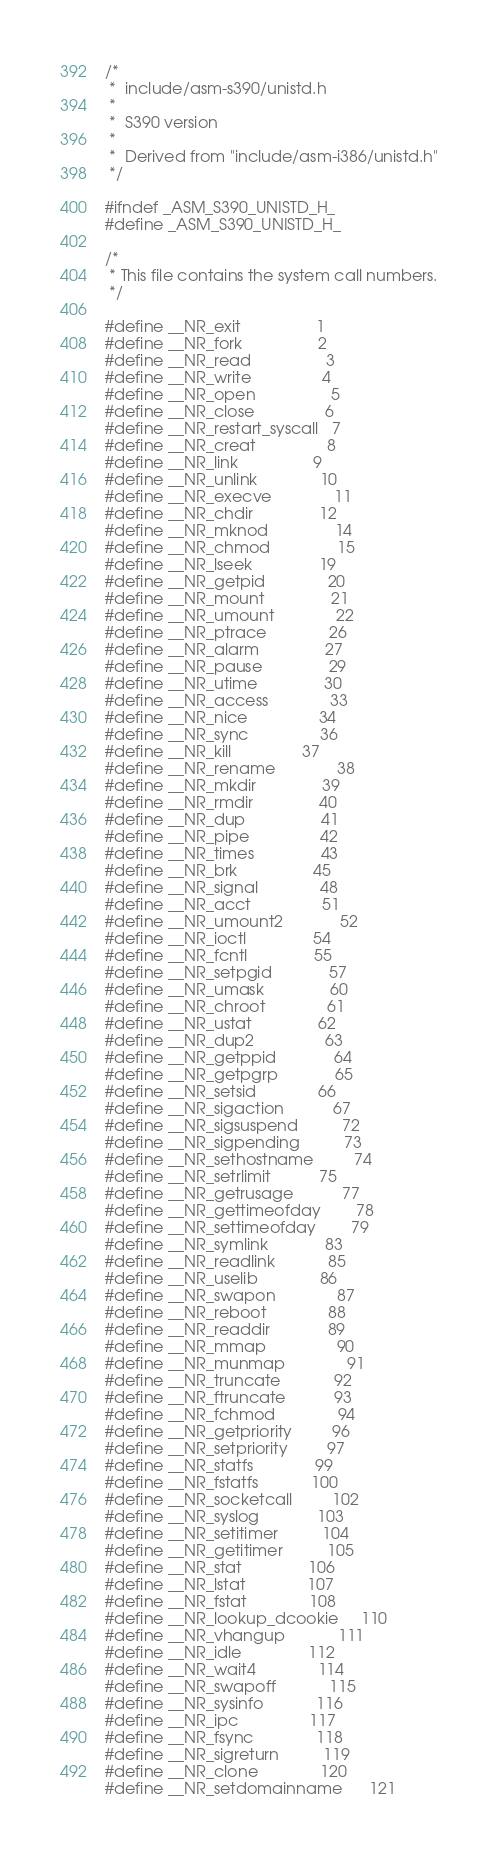<code> <loc_0><loc_0><loc_500><loc_500><_C_>/*
 *  include/asm-s390/unistd.h
 *
 *  S390 version
 *
 *  Derived from "include/asm-i386/unistd.h"
 */

#ifndef _ASM_S390_UNISTD_H_
#define _ASM_S390_UNISTD_H_

/*
 * This file contains the system call numbers.
 */

#define __NR_exit                 1
#define __NR_fork                 2
#define __NR_read                 3
#define __NR_write                4
#define __NR_open                 5
#define __NR_close                6
#define __NR_restart_syscall	  7
#define __NR_creat                8
#define __NR_link                 9
#define __NR_unlink              10
#define __NR_execve              11
#define __NR_chdir               12
#define __NR_mknod               14
#define __NR_chmod               15
#define __NR_lseek               19
#define __NR_getpid              20
#define __NR_mount               21
#define __NR_umount              22
#define __NR_ptrace              26
#define __NR_alarm               27
#define __NR_pause               29
#define __NR_utime               30
#define __NR_access              33
#define __NR_nice                34
#define __NR_sync                36
#define __NR_kill                37
#define __NR_rename              38
#define __NR_mkdir               39
#define __NR_rmdir               40
#define __NR_dup                 41
#define __NR_pipe                42
#define __NR_times               43
#define __NR_brk                 45
#define __NR_signal              48
#define __NR_acct                51
#define __NR_umount2             52
#define __NR_ioctl               54
#define __NR_fcntl               55
#define __NR_setpgid             57
#define __NR_umask               60
#define __NR_chroot              61
#define __NR_ustat               62
#define __NR_dup2                63
#define __NR_getppid             64
#define __NR_getpgrp             65
#define __NR_setsid              66
#define __NR_sigaction           67
#define __NR_sigsuspend          72
#define __NR_sigpending          73
#define __NR_sethostname         74
#define __NR_setrlimit           75
#define __NR_getrusage           77
#define __NR_gettimeofday        78
#define __NR_settimeofday        79
#define __NR_symlink             83
#define __NR_readlink            85
#define __NR_uselib              86
#define __NR_swapon              87
#define __NR_reboot              88
#define __NR_readdir             89
#define __NR_mmap                90
#define __NR_munmap              91
#define __NR_truncate            92
#define __NR_ftruncate           93
#define __NR_fchmod              94
#define __NR_getpriority         96
#define __NR_setpriority         97
#define __NR_statfs              99
#define __NR_fstatfs            100
#define __NR_socketcall         102
#define __NR_syslog             103
#define __NR_setitimer          104
#define __NR_getitimer          105
#define __NR_stat               106
#define __NR_lstat              107
#define __NR_fstat              108
#define __NR_lookup_dcookie     110
#define __NR_vhangup            111
#define __NR_idle               112
#define __NR_wait4              114
#define __NR_swapoff            115
#define __NR_sysinfo            116
#define __NR_ipc                117
#define __NR_fsync              118
#define __NR_sigreturn          119
#define __NR_clone              120
#define __NR_setdomainname      121</code> 